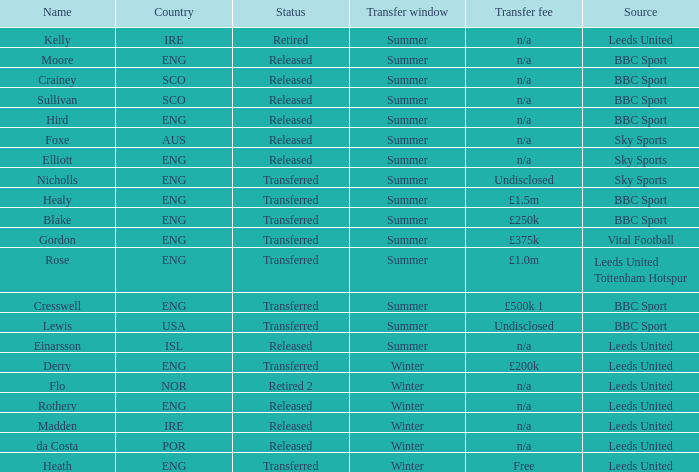What was the basis for the person called cresswell? BBC Sport. 